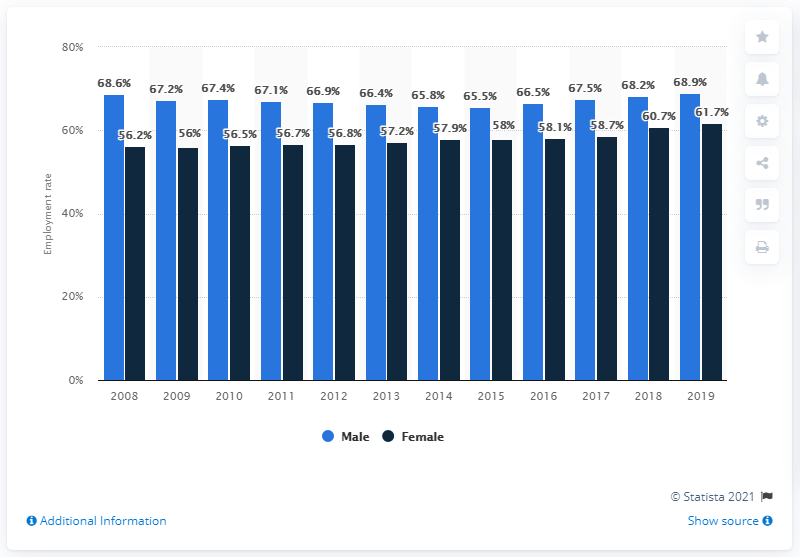Point out several critical features in this image. The male employment rate in Belgium in 2019 was 68.9 percent. According to data from 2015, the employment rate of men was 65.5%. According to data from 2019, the female employment rate in Belgium was 61.7%. In 2019, there was a difference of 7.2% between the number of male and female students. 